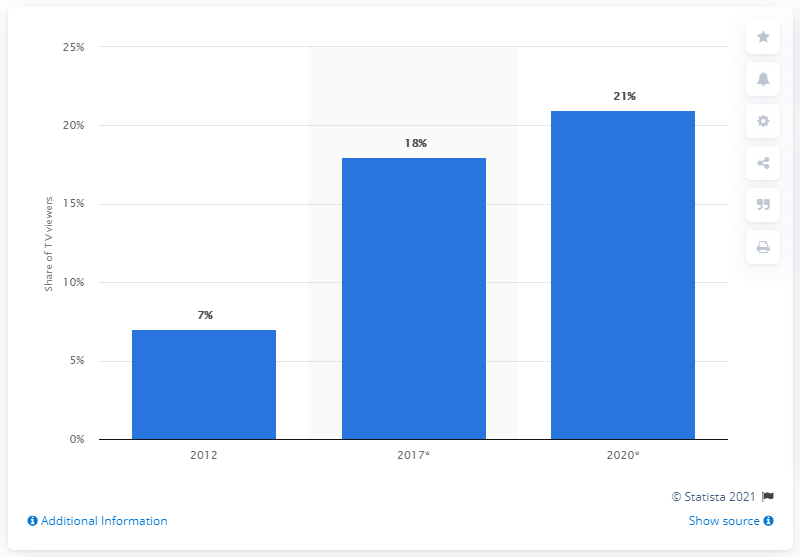Mention a couple of crucial points in this snapshot. In 2012, the pay TV penetration in Indonesia was first measured. 